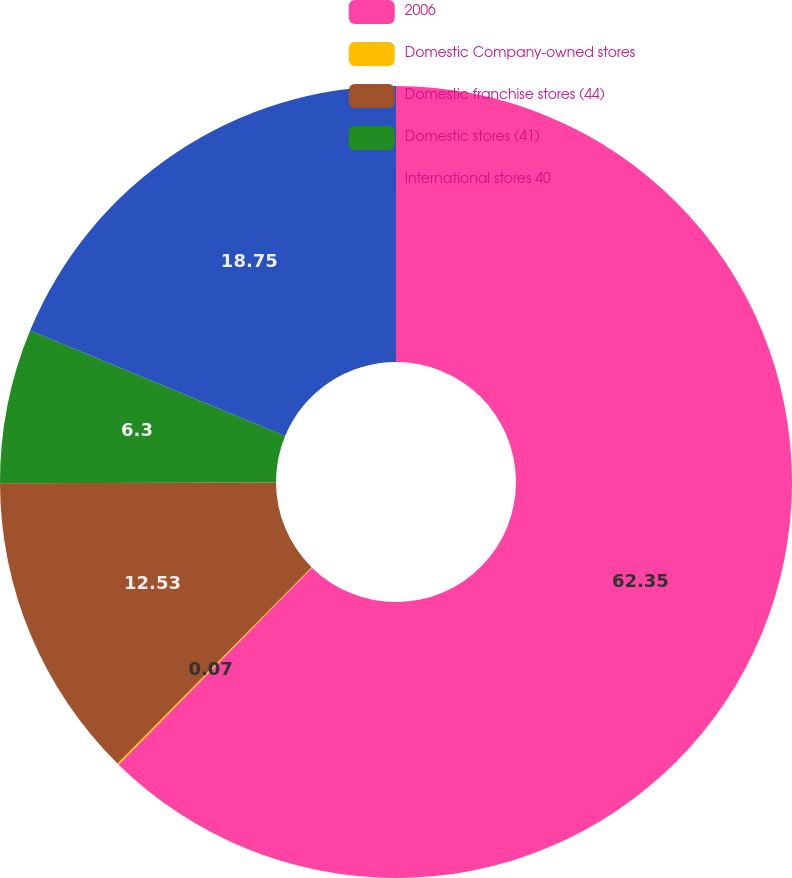<chart> <loc_0><loc_0><loc_500><loc_500><pie_chart><fcel>2006<fcel>Domestic Company-owned stores<fcel>Domestic franchise stores (44)<fcel>Domestic stores (41)<fcel>International stores 40<nl><fcel>62.35%<fcel>0.07%<fcel>12.53%<fcel>6.3%<fcel>18.75%<nl></chart> 